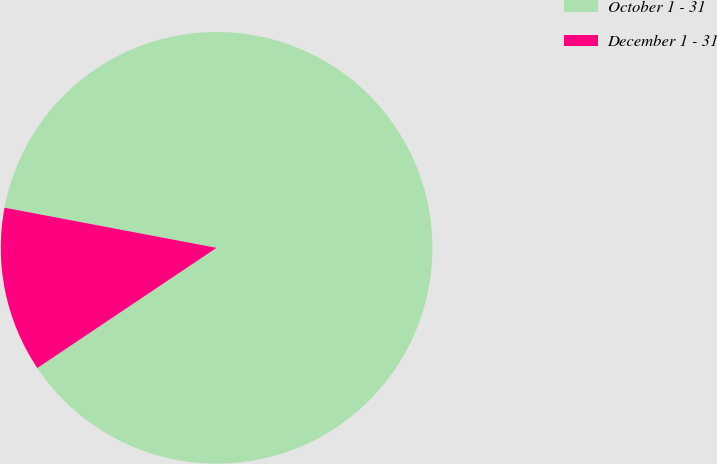Convert chart to OTSL. <chart><loc_0><loc_0><loc_500><loc_500><pie_chart><fcel>October 1 - 31<fcel>December 1 - 31<nl><fcel>87.62%<fcel>12.38%<nl></chart> 